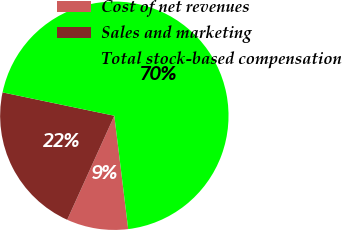<chart> <loc_0><loc_0><loc_500><loc_500><pie_chart><fcel>Cost of net revenues<fcel>Sales and marketing<fcel>Total stock-based compensation<nl><fcel>8.71%<fcel>21.51%<fcel>69.78%<nl></chart> 